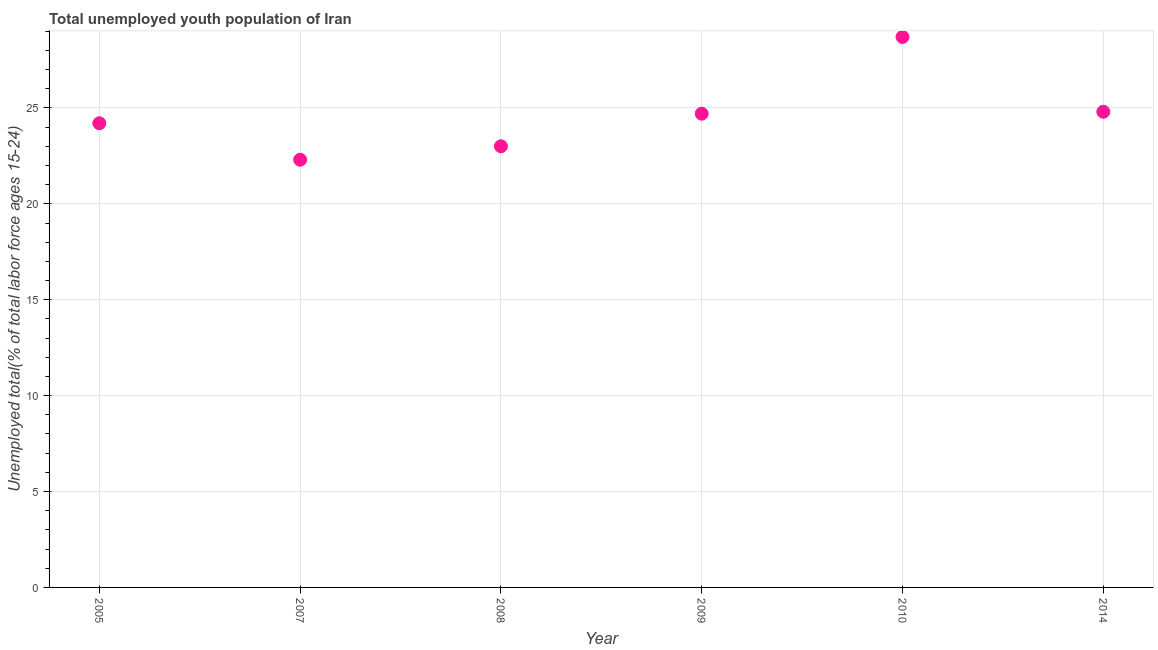What is the unemployed youth in 2014?
Ensure brevity in your answer.  24.8. Across all years, what is the maximum unemployed youth?
Make the answer very short. 28.7. Across all years, what is the minimum unemployed youth?
Make the answer very short. 22.3. In which year was the unemployed youth maximum?
Make the answer very short. 2010. What is the sum of the unemployed youth?
Your answer should be compact. 147.7. What is the difference between the unemployed youth in 2009 and 2010?
Your answer should be compact. -4. What is the average unemployed youth per year?
Your answer should be very brief. 24.62. What is the median unemployed youth?
Give a very brief answer. 24.45. What is the ratio of the unemployed youth in 2009 to that in 2014?
Keep it short and to the point. 1. Is the unemployed youth in 2005 less than that in 2014?
Ensure brevity in your answer.  Yes. What is the difference between the highest and the second highest unemployed youth?
Ensure brevity in your answer.  3.9. Is the sum of the unemployed youth in 2008 and 2010 greater than the maximum unemployed youth across all years?
Offer a terse response. Yes. What is the difference between the highest and the lowest unemployed youth?
Your response must be concise. 6.4. In how many years, is the unemployed youth greater than the average unemployed youth taken over all years?
Give a very brief answer. 3. Does the unemployed youth monotonically increase over the years?
Your answer should be compact. No. How many dotlines are there?
Provide a short and direct response. 1. What is the difference between two consecutive major ticks on the Y-axis?
Your answer should be compact. 5. Are the values on the major ticks of Y-axis written in scientific E-notation?
Your answer should be very brief. No. Does the graph contain any zero values?
Your response must be concise. No. What is the title of the graph?
Provide a short and direct response. Total unemployed youth population of Iran. What is the label or title of the Y-axis?
Ensure brevity in your answer.  Unemployed total(% of total labor force ages 15-24). What is the Unemployed total(% of total labor force ages 15-24) in 2005?
Ensure brevity in your answer.  24.2. What is the Unemployed total(% of total labor force ages 15-24) in 2007?
Your answer should be compact. 22.3. What is the Unemployed total(% of total labor force ages 15-24) in 2009?
Give a very brief answer. 24.7. What is the Unemployed total(% of total labor force ages 15-24) in 2010?
Offer a very short reply. 28.7. What is the Unemployed total(% of total labor force ages 15-24) in 2014?
Keep it short and to the point. 24.8. What is the difference between the Unemployed total(% of total labor force ages 15-24) in 2005 and 2010?
Keep it short and to the point. -4.5. What is the difference between the Unemployed total(% of total labor force ages 15-24) in 2005 and 2014?
Your answer should be compact. -0.6. What is the difference between the Unemployed total(% of total labor force ages 15-24) in 2007 and 2008?
Provide a short and direct response. -0.7. What is the difference between the Unemployed total(% of total labor force ages 15-24) in 2007 and 2014?
Your response must be concise. -2.5. What is the difference between the Unemployed total(% of total labor force ages 15-24) in 2009 and 2010?
Provide a short and direct response. -4. What is the ratio of the Unemployed total(% of total labor force ages 15-24) in 2005 to that in 2007?
Ensure brevity in your answer.  1.08. What is the ratio of the Unemployed total(% of total labor force ages 15-24) in 2005 to that in 2008?
Make the answer very short. 1.05. What is the ratio of the Unemployed total(% of total labor force ages 15-24) in 2005 to that in 2010?
Keep it short and to the point. 0.84. What is the ratio of the Unemployed total(% of total labor force ages 15-24) in 2005 to that in 2014?
Ensure brevity in your answer.  0.98. What is the ratio of the Unemployed total(% of total labor force ages 15-24) in 2007 to that in 2009?
Your answer should be very brief. 0.9. What is the ratio of the Unemployed total(% of total labor force ages 15-24) in 2007 to that in 2010?
Provide a short and direct response. 0.78. What is the ratio of the Unemployed total(% of total labor force ages 15-24) in 2007 to that in 2014?
Offer a terse response. 0.9. What is the ratio of the Unemployed total(% of total labor force ages 15-24) in 2008 to that in 2010?
Your response must be concise. 0.8. What is the ratio of the Unemployed total(% of total labor force ages 15-24) in 2008 to that in 2014?
Provide a short and direct response. 0.93. What is the ratio of the Unemployed total(% of total labor force ages 15-24) in 2009 to that in 2010?
Provide a short and direct response. 0.86. What is the ratio of the Unemployed total(% of total labor force ages 15-24) in 2009 to that in 2014?
Ensure brevity in your answer.  1. What is the ratio of the Unemployed total(% of total labor force ages 15-24) in 2010 to that in 2014?
Provide a succinct answer. 1.16. 